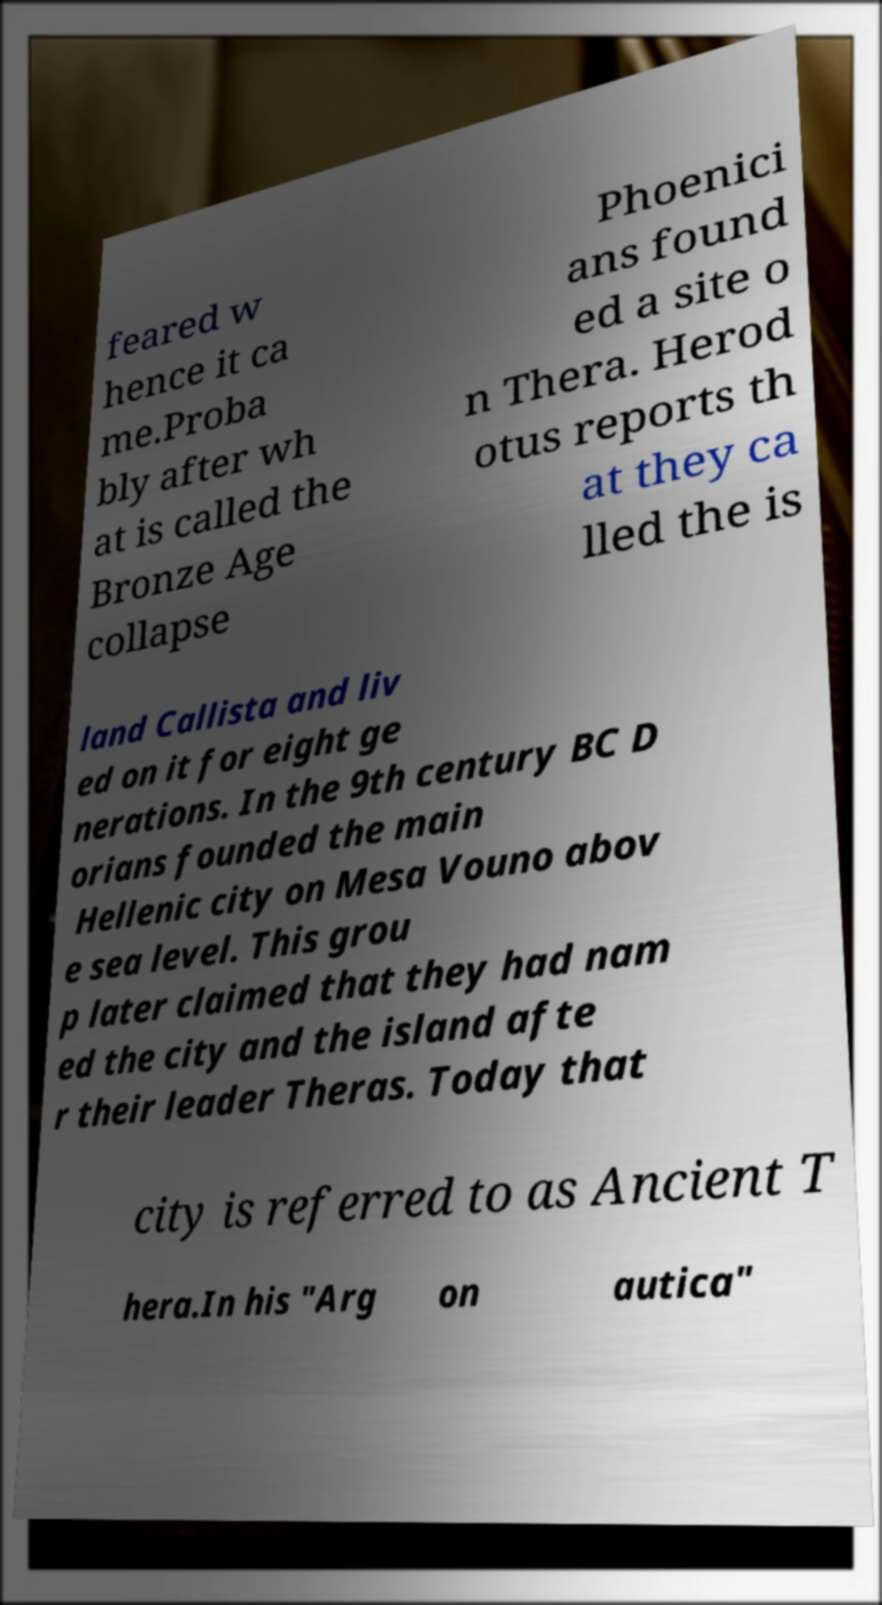There's text embedded in this image that I need extracted. Can you transcribe it verbatim? feared w hence it ca me.Proba bly after wh at is called the Bronze Age collapse Phoenici ans found ed a site o n Thera. Herod otus reports th at they ca lled the is land Callista and liv ed on it for eight ge nerations. In the 9th century BC D orians founded the main Hellenic city on Mesa Vouno abov e sea level. This grou p later claimed that they had nam ed the city and the island afte r their leader Theras. Today that city is referred to as Ancient T hera.In his "Arg on autica" 